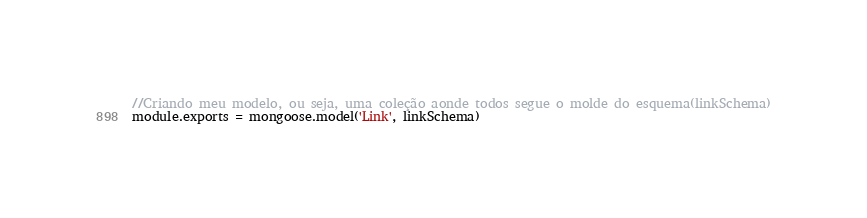Convert code to text. <code><loc_0><loc_0><loc_500><loc_500><_JavaScript_>
//Criando meu modelo, ou seja, uma coleção aonde todos segue o molde do esquema(linkSchema)
module.exports = mongoose.model('Link', linkSchema) 
</code> 